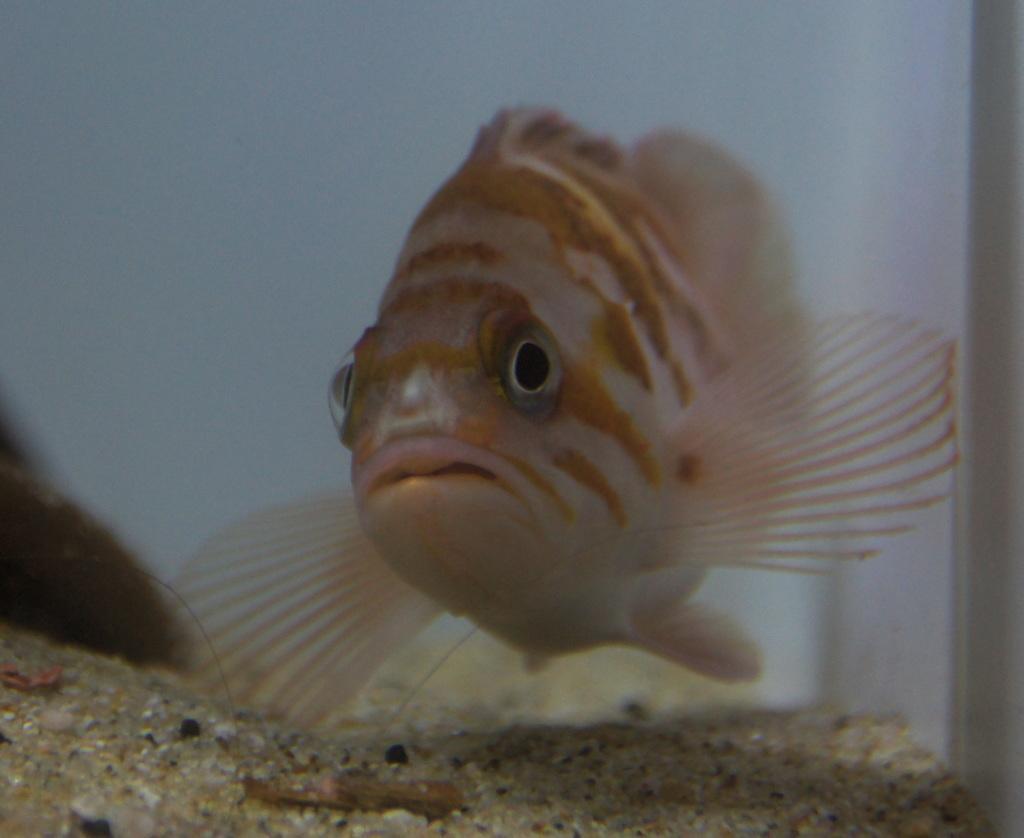How would you summarize this image in a sentence or two? In this image I can see a fish in the water and submarine sand. It looks as if the image is taken in a house in the aquarium. 